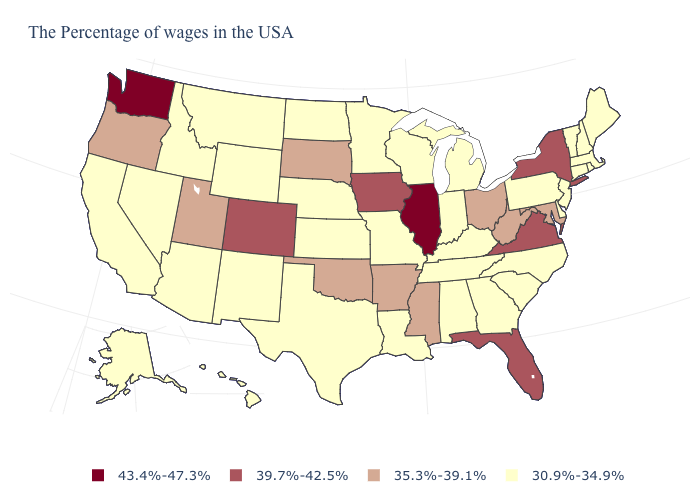Name the states that have a value in the range 35.3%-39.1%?
Short answer required. Maryland, West Virginia, Ohio, Mississippi, Arkansas, Oklahoma, South Dakota, Utah, Oregon. Name the states that have a value in the range 30.9%-34.9%?
Be succinct. Maine, Massachusetts, Rhode Island, New Hampshire, Vermont, Connecticut, New Jersey, Delaware, Pennsylvania, North Carolina, South Carolina, Georgia, Michigan, Kentucky, Indiana, Alabama, Tennessee, Wisconsin, Louisiana, Missouri, Minnesota, Kansas, Nebraska, Texas, North Dakota, Wyoming, New Mexico, Montana, Arizona, Idaho, Nevada, California, Alaska, Hawaii. Does the first symbol in the legend represent the smallest category?
Concise answer only. No. Name the states that have a value in the range 39.7%-42.5%?
Short answer required. New York, Virginia, Florida, Iowa, Colorado. Name the states that have a value in the range 30.9%-34.9%?
Keep it brief. Maine, Massachusetts, Rhode Island, New Hampshire, Vermont, Connecticut, New Jersey, Delaware, Pennsylvania, North Carolina, South Carolina, Georgia, Michigan, Kentucky, Indiana, Alabama, Tennessee, Wisconsin, Louisiana, Missouri, Minnesota, Kansas, Nebraska, Texas, North Dakota, Wyoming, New Mexico, Montana, Arizona, Idaho, Nevada, California, Alaska, Hawaii. What is the highest value in the USA?
Write a very short answer. 43.4%-47.3%. Name the states that have a value in the range 30.9%-34.9%?
Short answer required. Maine, Massachusetts, Rhode Island, New Hampshire, Vermont, Connecticut, New Jersey, Delaware, Pennsylvania, North Carolina, South Carolina, Georgia, Michigan, Kentucky, Indiana, Alabama, Tennessee, Wisconsin, Louisiana, Missouri, Minnesota, Kansas, Nebraska, Texas, North Dakota, Wyoming, New Mexico, Montana, Arizona, Idaho, Nevada, California, Alaska, Hawaii. What is the highest value in the USA?
Keep it brief. 43.4%-47.3%. Does Oklahoma have the same value as Tennessee?
Short answer required. No. Does the first symbol in the legend represent the smallest category?
Quick response, please. No. Which states have the lowest value in the South?
Keep it brief. Delaware, North Carolina, South Carolina, Georgia, Kentucky, Alabama, Tennessee, Louisiana, Texas. Among the states that border Arkansas , does Oklahoma have the highest value?
Keep it brief. Yes. Name the states that have a value in the range 35.3%-39.1%?
Concise answer only. Maryland, West Virginia, Ohio, Mississippi, Arkansas, Oklahoma, South Dakota, Utah, Oregon. Which states have the lowest value in the Northeast?
Give a very brief answer. Maine, Massachusetts, Rhode Island, New Hampshire, Vermont, Connecticut, New Jersey, Pennsylvania. 